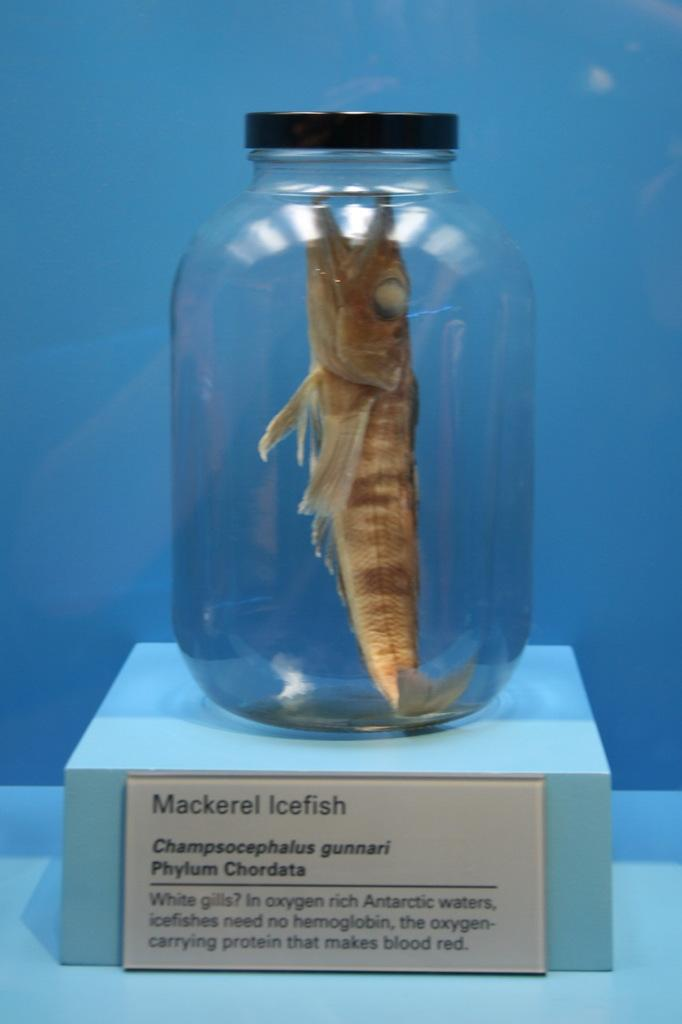What is the main subject of the image? There is a fish in the image. Where is the fish located? The fish is in a bottle. What is the bottle resting on? The bottle is on a cardboard surface. What is the color of the background in the image? The background of the image has a bluish color. What is written on the cardboard? There is text on the cardboard. What type of fruit is being tested in the image? There is no fruit present in the image, nor is there any indication of a test being conducted. 